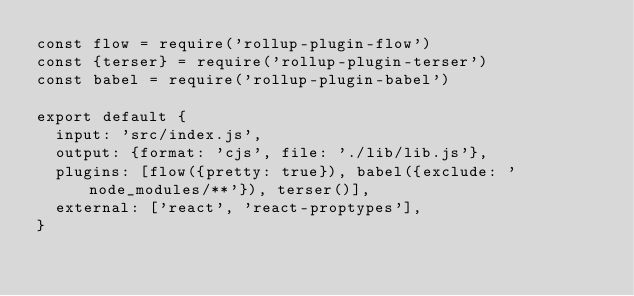Convert code to text. <code><loc_0><loc_0><loc_500><loc_500><_JavaScript_>const flow = require('rollup-plugin-flow')
const {terser} = require('rollup-plugin-terser')
const babel = require('rollup-plugin-babel')

export default {
  input: 'src/index.js',
  output: {format: 'cjs', file: './lib/lib.js'},
  plugins: [flow({pretty: true}), babel({exclude: 'node_modules/**'}), terser()],
  external: ['react', 'react-proptypes'],
}
</code> 